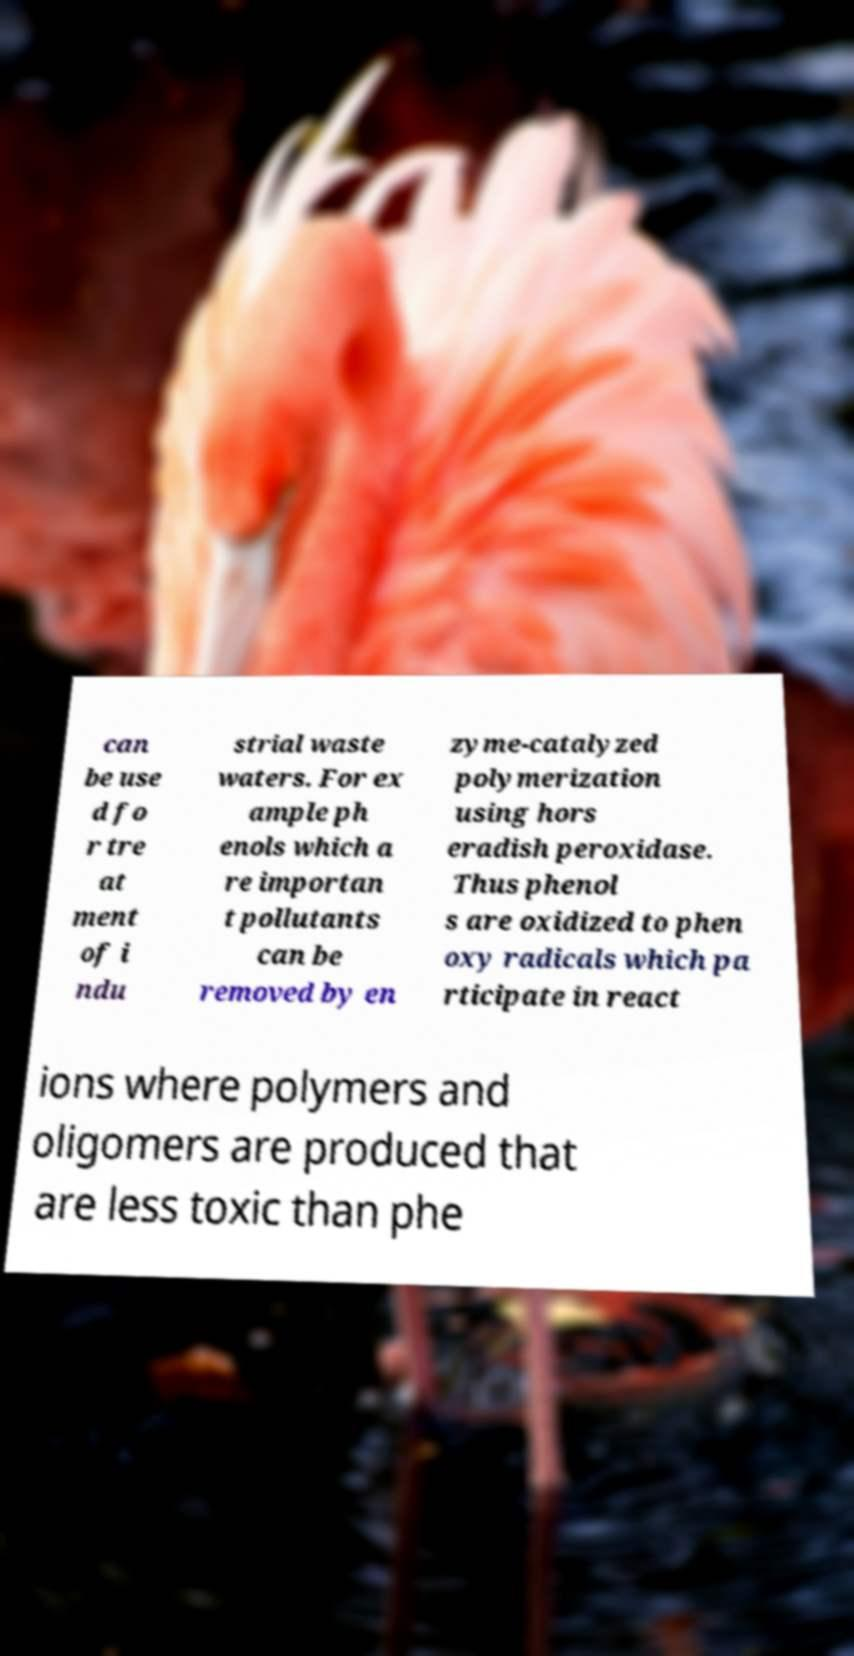What messages or text are displayed in this image? I need them in a readable, typed format. can be use d fo r tre at ment of i ndu strial waste waters. For ex ample ph enols which a re importan t pollutants can be removed by en zyme-catalyzed polymerization using hors eradish peroxidase. Thus phenol s are oxidized to phen oxy radicals which pa rticipate in react ions where polymers and oligomers are produced that are less toxic than phe 